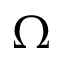Convert formula to latex. <formula><loc_0><loc_0><loc_500><loc_500>\Omega</formula> 